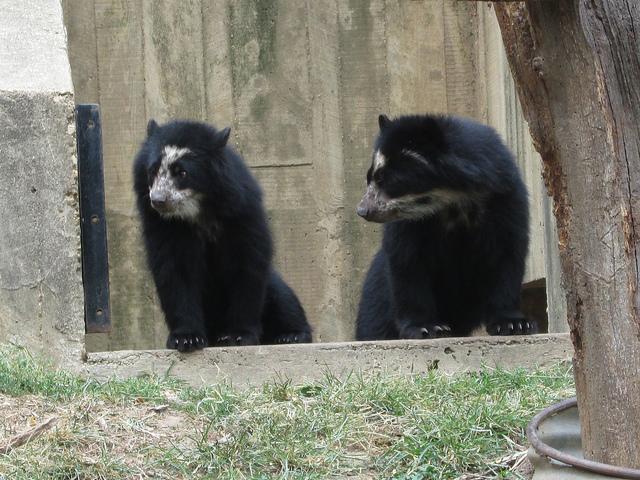How many animals are there?
Give a very brief answer. 2. How many bears are there?
Give a very brief answer. 2. 